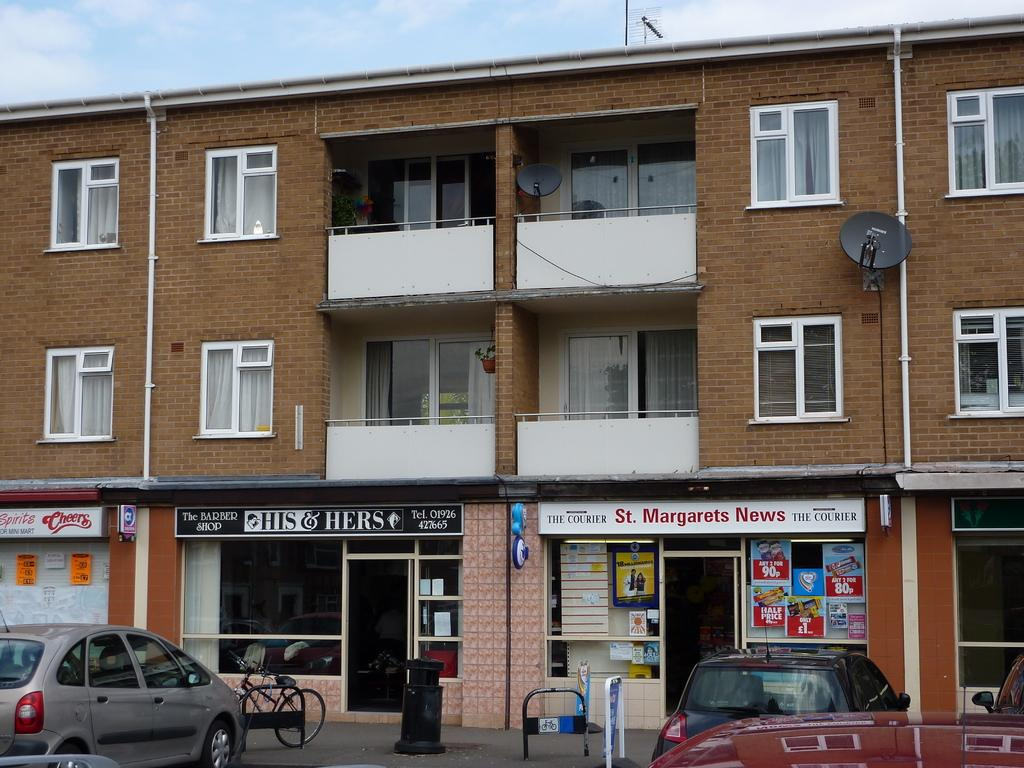What types of vehicles are at the bottom of the image? There are cars and a bicycle at the bottom of the image. What object can be found near the vehicles? There is a dustbin at the bottom of the image. What structure is present at the bottom of the image? There is a board at the bottom of the image. What is the surface at the bottom of the image? There is a road at the bottom of the image. What can be seen in the middle of the image? There are buildings in the middle of the image. What is visible at the top of the image? There is sky visible at the top of the image. What type of eggnog is being served at the top of the image? There is no eggnog present in the image. What record is being attempted by the person riding the bicycle? There is no person riding the bicycle in the image, nor is there any indication of a record being attempted. 